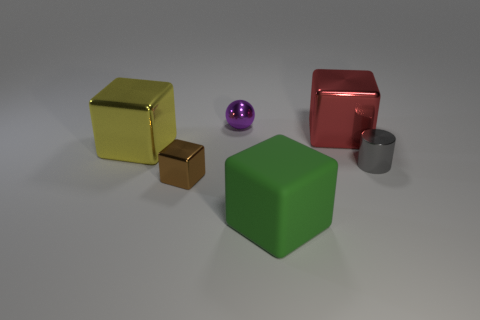Add 3 tiny metallic spheres. How many objects exist? 9 Subtract all cylinders. How many objects are left? 5 Add 5 red blocks. How many red blocks are left? 6 Add 4 small blue rubber spheres. How many small blue rubber spheres exist? 4 Subtract 0 gray spheres. How many objects are left? 6 Subtract all tiny metallic cylinders. Subtract all tiny brown metal objects. How many objects are left? 4 